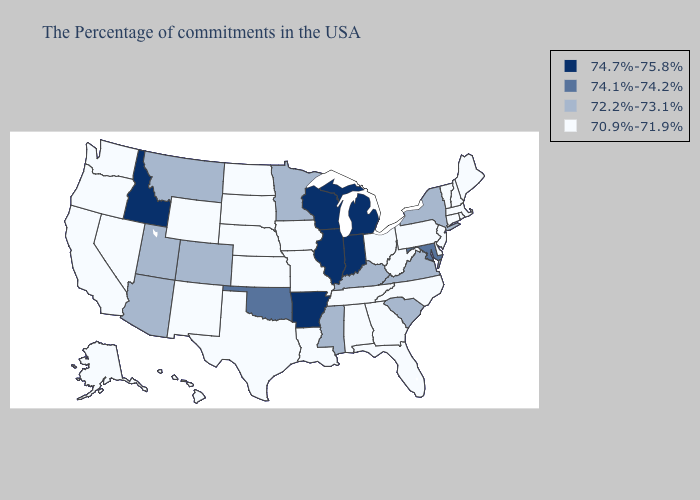Name the states that have a value in the range 74.7%-75.8%?
Be succinct. Michigan, Indiana, Wisconsin, Illinois, Arkansas, Idaho. What is the highest value in the USA?
Concise answer only. 74.7%-75.8%. Does the map have missing data?
Keep it brief. No. What is the highest value in the MidWest ?
Be succinct. 74.7%-75.8%. Name the states that have a value in the range 70.9%-71.9%?
Concise answer only. Maine, Massachusetts, Rhode Island, New Hampshire, Vermont, Connecticut, New Jersey, Delaware, Pennsylvania, North Carolina, West Virginia, Ohio, Florida, Georgia, Alabama, Tennessee, Louisiana, Missouri, Iowa, Kansas, Nebraska, Texas, South Dakota, North Dakota, Wyoming, New Mexico, Nevada, California, Washington, Oregon, Alaska, Hawaii. How many symbols are there in the legend?
Short answer required. 4. What is the lowest value in the USA?
Be succinct. 70.9%-71.9%. How many symbols are there in the legend?
Give a very brief answer. 4. Name the states that have a value in the range 72.2%-73.1%?
Keep it brief. New York, Virginia, South Carolina, Kentucky, Mississippi, Minnesota, Colorado, Utah, Montana, Arizona. Among the states that border North Dakota , which have the highest value?
Short answer required. Minnesota, Montana. Name the states that have a value in the range 74.1%-74.2%?
Short answer required. Maryland, Oklahoma. Among the states that border California , which have the highest value?
Quick response, please. Arizona. Among the states that border Nevada , which have the highest value?
Give a very brief answer. Idaho. Does New York have the highest value in the Northeast?
Concise answer only. Yes. Which states have the lowest value in the USA?
Write a very short answer. Maine, Massachusetts, Rhode Island, New Hampshire, Vermont, Connecticut, New Jersey, Delaware, Pennsylvania, North Carolina, West Virginia, Ohio, Florida, Georgia, Alabama, Tennessee, Louisiana, Missouri, Iowa, Kansas, Nebraska, Texas, South Dakota, North Dakota, Wyoming, New Mexico, Nevada, California, Washington, Oregon, Alaska, Hawaii. 